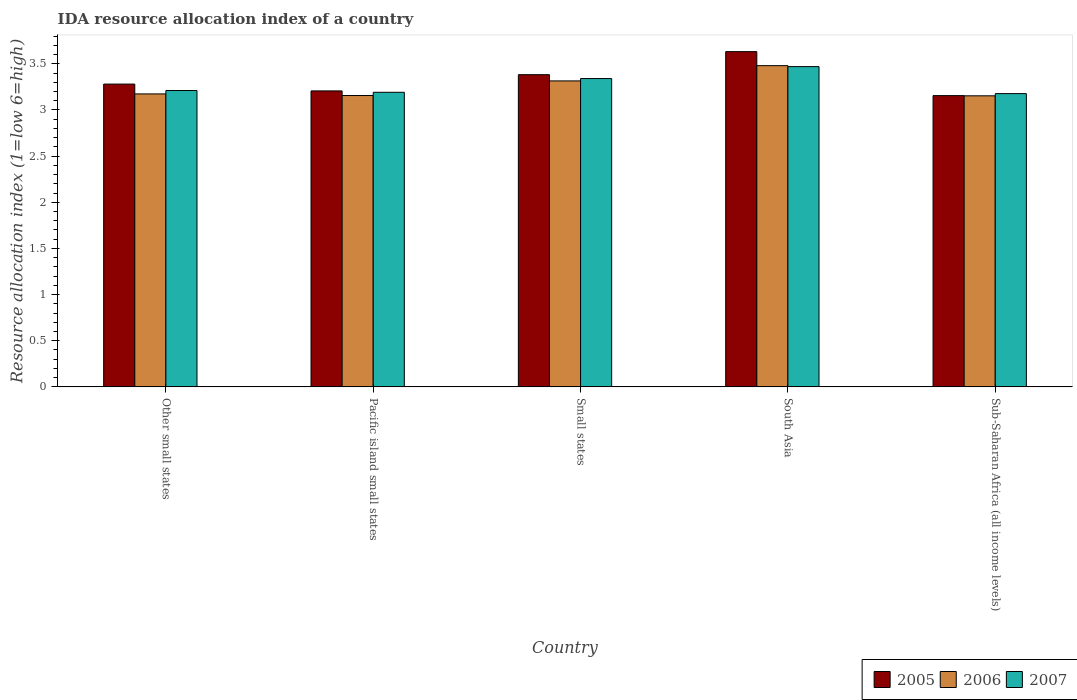How many different coloured bars are there?
Give a very brief answer. 3. How many groups of bars are there?
Ensure brevity in your answer.  5. Are the number of bars per tick equal to the number of legend labels?
Your response must be concise. Yes. How many bars are there on the 2nd tick from the left?
Provide a short and direct response. 3. What is the label of the 5th group of bars from the left?
Ensure brevity in your answer.  Sub-Saharan Africa (all income levels). In how many cases, is the number of bars for a given country not equal to the number of legend labels?
Offer a terse response. 0. What is the IDA resource allocation index in 2005 in Small states?
Ensure brevity in your answer.  3.38. Across all countries, what is the maximum IDA resource allocation index in 2006?
Offer a terse response. 3.48. Across all countries, what is the minimum IDA resource allocation index in 2007?
Ensure brevity in your answer.  3.18. In which country was the IDA resource allocation index in 2005 maximum?
Your response must be concise. South Asia. In which country was the IDA resource allocation index in 2006 minimum?
Offer a very short reply. Sub-Saharan Africa (all income levels). What is the total IDA resource allocation index in 2006 in the graph?
Offer a terse response. 16.28. What is the difference between the IDA resource allocation index in 2007 in Other small states and that in Sub-Saharan Africa (all income levels)?
Ensure brevity in your answer.  0.03. What is the difference between the IDA resource allocation index in 2005 in Small states and the IDA resource allocation index in 2006 in Pacific island small states?
Provide a short and direct response. 0.23. What is the average IDA resource allocation index in 2005 per country?
Provide a short and direct response. 3.33. What is the difference between the IDA resource allocation index of/in 2006 and IDA resource allocation index of/in 2005 in Small states?
Offer a very short reply. -0.07. In how many countries, is the IDA resource allocation index in 2007 greater than 1.4?
Provide a succinct answer. 5. What is the ratio of the IDA resource allocation index in 2007 in South Asia to that in Sub-Saharan Africa (all income levels)?
Your answer should be compact. 1.09. What is the difference between the highest and the second highest IDA resource allocation index in 2007?
Provide a short and direct response. 0.13. What is the difference between the highest and the lowest IDA resource allocation index in 2006?
Offer a very short reply. 0.33. Is the sum of the IDA resource allocation index in 2007 in Small states and Sub-Saharan Africa (all income levels) greater than the maximum IDA resource allocation index in 2006 across all countries?
Your response must be concise. Yes. What does the 2nd bar from the left in Pacific island small states represents?
Make the answer very short. 2006. What does the 2nd bar from the right in Other small states represents?
Offer a very short reply. 2006. Is it the case that in every country, the sum of the IDA resource allocation index in 2005 and IDA resource allocation index in 2006 is greater than the IDA resource allocation index in 2007?
Keep it short and to the point. Yes. Are the values on the major ticks of Y-axis written in scientific E-notation?
Offer a very short reply. No. Does the graph contain any zero values?
Make the answer very short. No. Does the graph contain grids?
Offer a terse response. No. Where does the legend appear in the graph?
Provide a succinct answer. Bottom right. How are the legend labels stacked?
Make the answer very short. Horizontal. What is the title of the graph?
Your answer should be compact. IDA resource allocation index of a country. Does "1978" appear as one of the legend labels in the graph?
Offer a terse response. No. What is the label or title of the Y-axis?
Provide a short and direct response. Resource allocation index (1=low 6=high). What is the Resource allocation index (1=low 6=high) in 2005 in Other small states?
Give a very brief answer. 3.28. What is the Resource allocation index (1=low 6=high) of 2006 in Other small states?
Provide a short and direct response. 3.17. What is the Resource allocation index (1=low 6=high) in 2007 in Other small states?
Your answer should be compact. 3.21. What is the Resource allocation index (1=low 6=high) of 2005 in Pacific island small states?
Give a very brief answer. 3.21. What is the Resource allocation index (1=low 6=high) in 2006 in Pacific island small states?
Make the answer very short. 3.16. What is the Resource allocation index (1=low 6=high) in 2007 in Pacific island small states?
Give a very brief answer. 3.19. What is the Resource allocation index (1=low 6=high) in 2005 in Small states?
Ensure brevity in your answer.  3.38. What is the Resource allocation index (1=low 6=high) of 2006 in Small states?
Give a very brief answer. 3.31. What is the Resource allocation index (1=low 6=high) of 2007 in Small states?
Your response must be concise. 3.34. What is the Resource allocation index (1=low 6=high) in 2005 in South Asia?
Offer a very short reply. 3.63. What is the Resource allocation index (1=low 6=high) of 2006 in South Asia?
Offer a terse response. 3.48. What is the Resource allocation index (1=low 6=high) in 2007 in South Asia?
Your answer should be compact. 3.47. What is the Resource allocation index (1=low 6=high) in 2005 in Sub-Saharan Africa (all income levels)?
Ensure brevity in your answer.  3.16. What is the Resource allocation index (1=low 6=high) of 2006 in Sub-Saharan Africa (all income levels)?
Give a very brief answer. 3.15. What is the Resource allocation index (1=low 6=high) of 2007 in Sub-Saharan Africa (all income levels)?
Ensure brevity in your answer.  3.18. Across all countries, what is the maximum Resource allocation index (1=low 6=high) in 2005?
Offer a terse response. 3.63. Across all countries, what is the maximum Resource allocation index (1=low 6=high) of 2006?
Your answer should be compact. 3.48. Across all countries, what is the maximum Resource allocation index (1=low 6=high) of 2007?
Your answer should be compact. 3.47. Across all countries, what is the minimum Resource allocation index (1=low 6=high) in 2005?
Your answer should be compact. 3.16. Across all countries, what is the minimum Resource allocation index (1=low 6=high) in 2006?
Provide a short and direct response. 3.15. Across all countries, what is the minimum Resource allocation index (1=low 6=high) of 2007?
Give a very brief answer. 3.18. What is the total Resource allocation index (1=low 6=high) of 2005 in the graph?
Provide a short and direct response. 16.66. What is the total Resource allocation index (1=low 6=high) in 2006 in the graph?
Your answer should be very brief. 16.28. What is the total Resource allocation index (1=low 6=high) of 2007 in the graph?
Offer a very short reply. 16.39. What is the difference between the Resource allocation index (1=low 6=high) of 2005 in Other small states and that in Pacific island small states?
Your answer should be very brief. 0.07. What is the difference between the Resource allocation index (1=low 6=high) of 2006 in Other small states and that in Pacific island small states?
Your answer should be very brief. 0.02. What is the difference between the Resource allocation index (1=low 6=high) of 2007 in Other small states and that in Pacific island small states?
Your response must be concise. 0.02. What is the difference between the Resource allocation index (1=low 6=high) of 2005 in Other small states and that in Small states?
Provide a short and direct response. -0.1. What is the difference between the Resource allocation index (1=low 6=high) in 2006 in Other small states and that in Small states?
Offer a very short reply. -0.14. What is the difference between the Resource allocation index (1=low 6=high) of 2007 in Other small states and that in Small states?
Offer a very short reply. -0.13. What is the difference between the Resource allocation index (1=low 6=high) of 2005 in Other small states and that in South Asia?
Your answer should be compact. -0.35. What is the difference between the Resource allocation index (1=low 6=high) of 2006 in Other small states and that in South Asia?
Your answer should be very brief. -0.31. What is the difference between the Resource allocation index (1=low 6=high) of 2007 in Other small states and that in South Asia?
Give a very brief answer. -0.26. What is the difference between the Resource allocation index (1=low 6=high) in 2005 in Other small states and that in Sub-Saharan Africa (all income levels)?
Ensure brevity in your answer.  0.12. What is the difference between the Resource allocation index (1=low 6=high) of 2006 in Other small states and that in Sub-Saharan Africa (all income levels)?
Ensure brevity in your answer.  0.02. What is the difference between the Resource allocation index (1=low 6=high) in 2007 in Other small states and that in Sub-Saharan Africa (all income levels)?
Your response must be concise. 0.03. What is the difference between the Resource allocation index (1=low 6=high) in 2005 in Pacific island small states and that in Small states?
Offer a very short reply. -0.18. What is the difference between the Resource allocation index (1=low 6=high) of 2006 in Pacific island small states and that in Small states?
Keep it short and to the point. -0.16. What is the difference between the Resource allocation index (1=low 6=high) in 2007 in Pacific island small states and that in Small states?
Ensure brevity in your answer.  -0.15. What is the difference between the Resource allocation index (1=low 6=high) in 2005 in Pacific island small states and that in South Asia?
Make the answer very short. -0.43. What is the difference between the Resource allocation index (1=low 6=high) of 2006 in Pacific island small states and that in South Asia?
Offer a terse response. -0.32. What is the difference between the Resource allocation index (1=low 6=high) of 2007 in Pacific island small states and that in South Asia?
Keep it short and to the point. -0.28. What is the difference between the Resource allocation index (1=low 6=high) of 2005 in Pacific island small states and that in Sub-Saharan Africa (all income levels)?
Keep it short and to the point. 0.05. What is the difference between the Resource allocation index (1=low 6=high) of 2006 in Pacific island small states and that in Sub-Saharan Africa (all income levels)?
Your response must be concise. 0. What is the difference between the Resource allocation index (1=low 6=high) of 2007 in Pacific island small states and that in Sub-Saharan Africa (all income levels)?
Your response must be concise. 0.01. What is the difference between the Resource allocation index (1=low 6=high) of 2005 in Small states and that in South Asia?
Provide a short and direct response. -0.25. What is the difference between the Resource allocation index (1=low 6=high) in 2006 in Small states and that in South Asia?
Your response must be concise. -0.17. What is the difference between the Resource allocation index (1=low 6=high) of 2007 in Small states and that in South Asia?
Your answer should be compact. -0.13. What is the difference between the Resource allocation index (1=low 6=high) of 2005 in Small states and that in Sub-Saharan Africa (all income levels)?
Your response must be concise. 0.23. What is the difference between the Resource allocation index (1=low 6=high) in 2006 in Small states and that in Sub-Saharan Africa (all income levels)?
Give a very brief answer. 0.16. What is the difference between the Resource allocation index (1=low 6=high) of 2007 in Small states and that in Sub-Saharan Africa (all income levels)?
Make the answer very short. 0.16. What is the difference between the Resource allocation index (1=low 6=high) of 2005 in South Asia and that in Sub-Saharan Africa (all income levels)?
Your response must be concise. 0.48. What is the difference between the Resource allocation index (1=low 6=high) in 2006 in South Asia and that in Sub-Saharan Africa (all income levels)?
Offer a terse response. 0.33. What is the difference between the Resource allocation index (1=low 6=high) in 2007 in South Asia and that in Sub-Saharan Africa (all income levels)?
Ensure brevity in your answer.  0.29. What is the difference between the Resource allocation index (1=low 6=high) of 2005 in Other small states and the Resource allocation index (1=low 6=high) of 2006 in Pacific island small states?
Offer a very short reply. 0.12. What is the difference between the Resource allocation index (1=low 6=high) of 2005 in Other small states and the Resource allocation index (1=low 6=high) of 2007 in Pacific island small states?
Give a very brief answer. 0.09. What is the difference between the Resource allocation index (1=low 6=high) of 2006 in Other small states and the Resource allocation index (1=low 6=high) of 2007 in Pacific island small states?
Provide a short and direct response. -0.02. What is the difference between the Resource allocation index (1=low 6=high) in 2005 in Other small states and the Resource allocation index (1=low 6=high) in 2006 in Small states?
Ensure brevity in your answer.  -0.03. What is the difference between the Resource allocation index (1=low 6=high) in 2005 in Other small states and the Resource allocation index (1=low 6=high) in 2007 in Small states?
Make the answer very short. -0.06. What is the difference between the Resource allocation index (1=low 6=high) in 2006 in Other small states and the Resource allocation index (1=low 6=high) in 2007 in Small states?
Your response must be concise. -0.17. What is the difference between the Resource allocation index (1=low 6=high) of 2005 in Other small states and the Resource allocation index (1=low 6=high) of 2006 in South Asia?
Provide a succinct answer. -0.2. What is the difference between the Resource allocation index (1=low 6=high) of 2005 in Other small states and the Resource allocation index (1=low 6=high) of 2007 in South Asia?
Your response must be concise. -0.19. What is the difference between the Resource allocation index (1=low 6=high) in 2006 in Other small states and the Resource allocation index (1=low 6=high) in 2007 in South Asia?
Make the answer very short. -0.3. What is the difference between the Resource allocation index (1=low 6=high) in 2005 in Other small states and the Resource allocation index (1=low 6=high) in 2006 in Sub-Saharan Africa (all income levels)?
Your response must be concise. 0.13. What is the difference between the Resource allocation index (1=low 6=high) of 2005 in Other small states and the Resource allocation index (1=low 6=high) of 2007 in Sub-Saharan Africa (all income levels)?
Provide a short and direct response. 0.1. What is the difference between the Resource allocation index (1=low 6=high) in 2006 in Other small states and the Resource allocation index (1=low 6=high) in 2007 in Sub-Saharan Africa (all income levels)?
Ensure brevity in your answer.  -0. What is the difference between the Resource allocation index (1=low 6=high) of 2005 in Pacific island small states and the Resource allocation index (1=low 6=high) of 2006 in Small states?
Offer a very short reply. -0.11. What is the difference between the Resource allocation index (1=low 6=high) of 2005 in Pacific island small states and the Resource allocation index (1=low 6=high) of 2007 in Small states?
Offer a very short reply. -0.13. What is the difference between the Resource allocation index (1=low 6=high) of 2006 in Pacific island small states and the Resource allocation index (1=low 6=high) of 2007 in Small states?
Give a very brief answer. -0.18. What is the difference between the Resource allocation index (1=low 6=high) of 2005 in Pacific island small states and the Resource allocation index (1=low 6=high) of 2006 in South Asia?
Provide a succinct answer. -0.27. What is the difference between the Resource allocation index (1=low 6=high) of 2005 in Pacific island small states and the Resource allocation index (1=low 6=high) of 2007 in South Asia?
Ensure brevity in your answer.  -0.26. What is the difference between the Resource allocation index (1=low 6=high) of 2006 in Pacific island small states and the Resource allocation index (1=low 6=high) of 2007 in South Asia?
Make the answer very short. -0.31. What is the difference between the Resource allocation index (1=low 6=high) of 2005 in Pacific island small states and the Resource allocation index (1=low 6=high) of 2006 in Sub-Saharan Africa (all income levels)?
Ensure brevity in your answer.  0.05. What is the difference between the Resource allocation index (1=low 6=high) in 2005 in Pacific island small states and the Resource allocation index (1=low 6=high) in 2007 in Sub-Saharan Africa (all income levels)?
Ensure brevity in your answer.  0.03. What is the difference between the Resource allocation index (1=low 6=high) of 2006 in Pacific island small states and the Resource allocation index (1=low 6=high) of 2007 in Sub-Saharan Africa (all income levels)?
Offer a very short reply. -0.02. What is the difference between the Resource allocation index (1=low 6=high) of 2005 in Small states and the Resource allocation index (1=low 6=high) of 2006 in South Asia?
Give a very brief answer. -0.1. What is the difference between the Resource allocation index (1=low 6=high) of 2005 in Small states and the Resource allocation index (1=low 6=high) of 2007 in South Asia?
Keep it short and to the point. -0.09. What is the difference between the Resource allocation index (1=low 6=high) of 2006 in Small states and the Resource allocation index (1=low 6=high) of 2007 in South Asia?
Your answer should be compact. -0.15. What is the difference between the Resource allocation index (1=low 6=high) in 2005 in Small states and the Resource allocation index (1=low 6=high) in 2006 in Sub-Saharan Africa (all income levels)?
Provide a short and direct response. 0.23. What is the difference between the Resource allocation index (1=low 6=high) of 2005 in Small states and the Resource allocation index (1=low 6=high) of 2007 in Sub-Saharan Africa (all income levels)?
Offer a terse response. 0.21. What is the difference between the Resource allocation index (1=low 6=high) of 2006 in Small states and the Resource allocation index (1=low 6=high) of 2007 in Sub-Saharan Africa (all income levels)?
Give a very brief answer. 0.14. What is the difference between the Resource allocation index (1=low 6=high) in 2005 in South Asia and the Resource allocation index (1=low 6=high) in 2006 in Sub-Saharan Africa (all income levels)?
Ensure brevity in your answer.  0.48. What is the difference between the Resource allocation index (1=low 6=high) of 2005 in South Asia and the Resource allocation index (1=low 6=high) of 2007 in Sub-Saharan Africa (all income levels)?
Your answer should be very brief. 0.45. What is the difference between the Resource allocation index (1=low 6=high) in 2006 in South Asia and the Resource allocation index (1=low 6=high) in 2007 in Sub-Saharan Africa (all income levels)?
Ensure brevity in your answer.  0.3. What is the average Resource allocation index (1=low 6=high) in 2005 per country?
Offer a very short reply. 3.33. What is the average Resource allocation index (1=low 6=high) of 2006 per country?
Keep it short and to the point. 3.26. What is the average Resource allocation index (1=low 6=high) of 2007 per country?
Make the answer very short. 3.28. What is the difference between the Resource allocation index (1=low 6=high) in 2005 and Resource allocation index (1=low 6=high) in 2006 in Other small states?
Give a very brief answer. 0.11. What is the difference between the Resource allocation index (1=low 6=high) of 2005 and Resource allocation index (1=low 6=high) of 2007 in Other small states?
Your answer should be compact. 0.07. What is the difference between the Resource allocation index (1=low 6=high) of 2006 and Resource allocation index (1=low 6=high) of 2007 in Other small states?
Keep it short and to the point. -0.04. What is the difference between the Resource allocation index (1=low 6=high) of 2005 and Resource allocation index (1=low 6=high) of 2007 in Pacific island small states?
Provide a short and direct response. 0.01. What is the difference between the Resource allocation index (1=low 6=high) of 2006 and Resource allocation index (1=low 6=high) of 2007 in Pacific island small states?
Your answer should be compact. -0.04. What is the difference between the Resource allocation index (1=low 6=high) in 2005 and Resource allocation index (1=low 6=high) in 2006 in Small states?
Your answer should be compact. 0.07. What is the difference between the Resource allocation index (1=low 6=high) of 2005 and Resource allocation index (1=low 6=high) of 2007 in Small states?
Offer a very short reply. 0.04. What is the difference between the Resource allocation index (1=low 6=high) of 2006 and Resource allocation index (1=low 6=high) of 2007 in Small states?
Make the answer very short. -0.03. What is the difference between the Resource allocation index (1=low 6=high) of 2005 and Resource allocation index (1=low 6=high) of 2006 in South Asia?
Make the answer very short. 0.15. What is the difference between the Resource allocation index (1=low 6=high) of 2005 and Resource allocation index (1=low 6=high) of 2007 in South Asia?
Provide a succinct answer. 0.16. What is the difference between the Resource allocation index (1=low 6=high) of 2006 and Resource allocation index (1=low 6=high) of 2007 in South Asia?
Offer a terse response. 0.01. What is the difference between the Resource allocation index (1=low 6=high) in 2005 and Resource allocation index (1=low 6=high) in 2006 in Sub-Saharan Africa (all income levels)?
Your answer should be very brief. 0. What is the difference between the Resource allocation index (1=low 6=high) of 2005 and Resource allocation index (1=low 6=high) of 2007 in Sub-Saharan Africa (all income levels)?
Make the answer very short. -0.02. What is the difference between the Resource allocation index (1=low 6=high) of 2006 and Resource allocation index (1=low 6=high) of 2007 in Sub-Saharan Africa (all income levels)?
Give a very brief answer. -0.02. What is the ratio of the Resource allocation index (1=low 6=high) of 2005 in Other small states to that in Pacific island small states?
Your response must be concise. 1.02. What is the ratio of the Resource allocation index (1=low 6=high) in 2007 in Other small states to that in Pacific island small states?
Give a very brief answer. 1.01. What is the ratio of the Resource allocation index (1=low 6=high) in 2005 in Other small states to that in Small states?
Keep it short and to the point. 0.97. What is the ratio of the Resource allocation index (1=low 6=high) of 2006 in Other small states to that in Small states?
Your response must be concise. 0.96. What is the ratio of the Resource allocation index (1=low 6=high) in 2007 in Other small states to that in Small states?
Offer a very short reply. 0.96. What is the ratio of the Resource allocation index (1=low 6=high) in 2005 in Other small states to that in South Asia?
Provide a succinct answer. 0.9. What is the ratio of the Resource allocation index (1=low 6=high) in 2006 in Other small states to that in South Asia?
Your answer should be compact. 0.91. What is the ratio of the Resource allocation index (1=low 6=high) in 2007 in Other small states to that in South Asia?
Offer a terse response. 0.93. What is the ratio of the Resource allocation index (1=low 6=high) of 2005 in Other small states to that in Sub-Saharan Africa (all income levels)?
Give a very brief answer. 1.04. What is the ratio of the Resource allocation index (1=low 6=high) in 2006 in Other small states to that in Sub-Saharan Africa (all income levels)?
Make the answer very short. 1.01. What is the ratio of the Resource allocation index (1=low 6=high) of 2007 in Other small states to that in Sub-Saharan Africa (all income levels)?
Your answer should be very brief. 1.01. What is the ratio of the Resource allocation index (1=low 6=high) in 2005 in Pacific island small states to that in Small states?
Offer a terse response. 0.95. What is the ratio of the Resource allocation index (1=low 6=high) in 2006 in Pacific island small states to that in Small states?
Ensure brevity in your answer.  0.95. What is the ratio of the Resource allocation index (1=low 6=high) of 2007 in Pacific island small states to that in Small states?
Ensure brevity in your answer.  0.96. What is the ratio of the Resource allocation index (1=low 6=high) of 2005 in Pacific island small states to that in South Asia?
Your answer should be compact. 0.88. What is the ratio of the Resource allocation index (1=low 6=high) in 2006 in Pacific island small states to that in South Asia?
Your answer should be very brief. 0.91. What is the ratio of the Resource allocation index (1=low 6=high) in 2007 in Pacific island small states to that in South Asia?
Provide a short and direct response. 0.92. What is the ratio of the Resource allocation index (1=low 6=high) in 2005 in Pacific island small states to that in Sub-Saharan Africa (all income levels)?
Provide a succinct answer. 1.02. What is the ratio of the Resource allocation index (1=low 6=high) in 2006 in Pacific island small states to that in Sub-Saharan Africa (all income levels)?
Keep it short and to the point. 1. What is the ratio of the Resource allocation index (1=low 6=high) in 2005 in Small states to that in South Asia?
Keep it short and to the point. 0.93. What is the ratio of the Resource allocation index (1=low 6=high) in 2006 in Small states to that in South Asia?
Provide a succinct answer. 0.95. What is the ratio of the Resource allocation index (1=low 6=high) of 2007 in Small states to that in South Asia?
Keep it short and to the point. 0.96. What is the ratio of the Resource allocation index (1=low 6=high) of 2005 in Small states to that in Sub-Saharan Africa (all income levels)?
Provide a succinct answer. 1.07. What is the ratio of the Resource allocation index (1=low 6=high) of 2006 in Small states to that in Sub-Saharan Africa (all income levels)?
Your answer should be very brief. 1.05. What is the ratio of the Resource allocation index (1=low 6=high) in 2007 in Small states to that in Sub-Saharan Africa (all income levels)?
Your answer should be compact. 1.05. What is the ratio of the Resource allocation index (1=low 6=high) in 2005 in South Asia to that in Sub-Saharan Africa (all income levels)?
Provide a succinct answer. 1.15. What is the ratio of the Resource allocation index (1=low 6=high) of 2006 in South Asia to that in Sub-Saharan Africa (all income levels)?
Your answer should be compact. 1.1. What is the ratio of the Resource allocation index (1=low 6=high) in 2007 in South Asia to that in Sub-Saharan Africa (all income levels)?
Offer a very short reply. 1.09. What is the difference between the highest and the second highest Resource allocation index (1=low 6=high) of 2005?
Provide a succinct answer. 0.25. What is the difference between the highest and the second highest Resource allocation index (1=low 6=high) of 2006?
Offer a terse response. 0.17. What is the difference between the highest and the second highest Resource allocation index (1=low 6=high) of 2007?
Ensure brevity in your answer.  0.13. What is the difference between the highest and the lowest Resource allocation index (1=low 6=high) of 2005?
Provide a succinct answer. 0.48. What is the difference between the highest and the lowest Resource allocation index (1=low 6=high) in 2006?
Keep it short and to the point. 0.33. What is the difference between the highest and the lowest Resource allocation index (1=low 6=high) in 2007?
Offer a terse response. 0.29. 